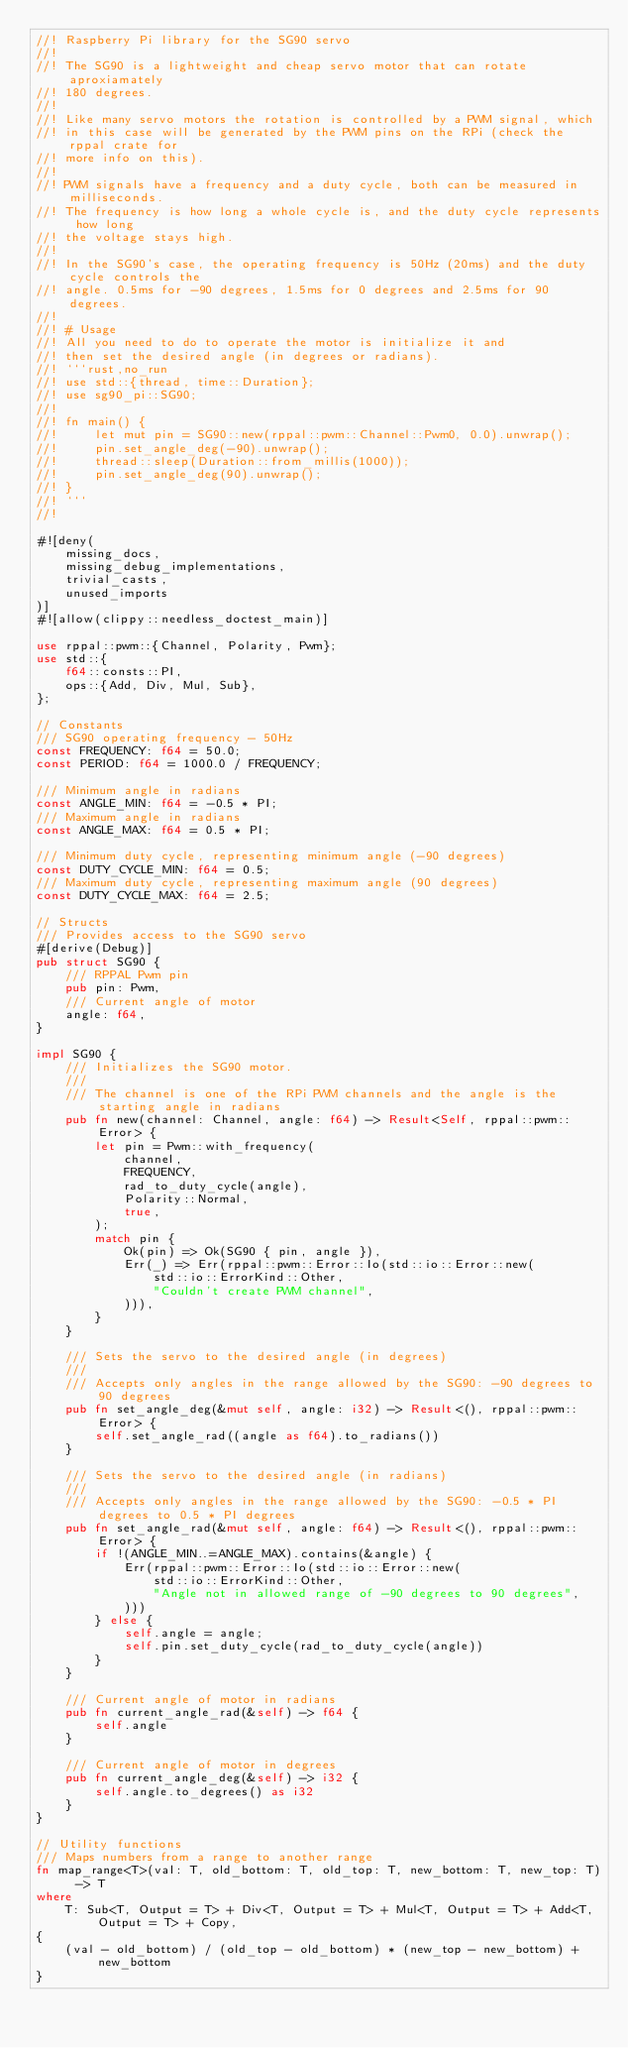<code> <loc_0><loc_0><loc_500><loc_500><_Rust_>//! Raspberry Pi library for the SG90 servo
//!
//! The SG90 is a lightweight and cheap servo motor that can rotate aproxiamately
//! 180 degrees.
//!
//! Like many servo motors the rotation is controlled by a PWM signal, which
//! in this case will be generated by the PWM pins on the RPi (check the rppal crate for
//! more info on this).
//!
//! PWM signals have a frequency and a duty cycle, both can be measured in milliseconds.
//! The frequency is how long a whole cycle is, and the duty cycle represents how long
//! the voltage stays high.
//!
//! In the SG90's case, the operating frequency is 50Hz (20ms) and the duty cycle controls the
//! angle. 0.5ms for -90 degrees, 1.5ms for 0 degrees and 2.5ms for 90 degrees.
//!
//! # Usage
//! All you need to do to operate the motor is initialize it and
//! then set the desired angle (in degrees or radians).
//! ```rust,no_run
//! use std::{thread, time::Duration};
//! use sg90_pi::SG90;
//!
//! fn main() {
//!     let mut pin = SG90::new(rppal::pwm::Channel::Pwm0, 0.0).unwrap();
//!     pin.set_angle_deg(-90).unwrap();
//!     thread::sleep(Duration::from_millis(1000));
//!     pin.set_angle_deg(90).unwrap();
//! }
//! ```
//!

#![deny(
    missing_docs,
    missing_debug_implementations,
    trivial_casts,
    unused_imports
)]
#![allow(clippy::needless_doctest_main)]

use rppal::pwm::{Channel, Polarity, Pwm};
use std::{
    f64::consts::PI,
    ops::{Add, Div, Mul, Sub},
};

// Constants
/// SG90 operating frequency - 50Hz
const FREQUENCY: f64 = 50.0;
const PERIOD: f64 = 1000.0 / FREQUENCY;

/// Minimum angle in radians
const ANGLE_MIN: f64 = -0.5 * PI;
/// Maximum angle in radians
const ANGLE_MAX: f64 = 0.5 * PI;

/// Minimum duty cycle, representing minimum angle (-90 degrees)
const DUTY_CYCLE_MIN: f64 = 0.5;
/// Maximum duty cycle, representing maximum angle (90 degrees)
const DUTY_CYCLE_MAX: f64 = 2.5;

// Structs
/// Provides access to the SG90 servo
#[derive(Debug)]
pub struct SG90 {
    /// RPPAL Pwm pin
    pub pin: Pwm,
    /// Current angle of motor
    angle: f64,
}

impl SG90 {
    /// Initializes the SG90 motor.
    ///
    /// The channel is one of the RPi PWM channels and the angle is the starting angle in radians
    pub fn new(channel: Channel, angle: f64) -> Result<Self, rppal::pwm::Error> {
        let pin = Pwm::with_frequency(
            channel,
            FREQUENCY,
            rad_to_duty_cycle(angle),
            Polarity::Normal,
            true,
        );
        match pin {
            Ok(pin) => Ok(SG90 { pin, angle }),
            Err(_) => Err(rppal::pwm::Error::Io(std::io::Error::new(
                std::io::ErrorKind::Other,
                "Couldn't create PWM channel",
            ))),
        }
    }

    /// Sets the servo to the desired angle (in degrees)
    ///
    /// Accepts only angles in the range allowed by the SG90: -90 degrees to 90 degrees
    pub fn set_angle_deg(&mut self, angle: i32) -> Result<(), rppal::pwm::Error> {
        self.set_angle_rad((angle as f64).to_radians())
    }

    /// Sets the servo to the desired angle (in radians)
    ///
    /// Accepts only angles in the range allowed by the SG90: -0.5 * PI degrees to 0.5 * PI degrees
    pub fn set_angle_rad(&mut self, angle: f64) -> Result<(), rppal::pwm::Error> {
        if !(ANGLE_MIN..=ANGLE_MAX).contains(&angle) {
            Err(rppal::pwm::Error::Io(std::io::Error::new(
                std::io::ErrorKind::Other,
                "Angle not in allowed range of -90 degrees to 90 degrees",
            )))
        } else {
            self.angle = angle;
            self.pin.set_duty_cycle(rad_to_duty_cycle(angle))
        }
    }

    /// Current angle of motor in radians
    pub fn current_angle_rad(&self) -> f64 {
        self.angle
    }

    /// Current angle of motor in degrees
    pub fn current_angle_deg(&self) -> i32 {
        self.angle.to_degrees() as i32
    }
}

// Utility functions
/// Maps numbers from a range to another range
fn map_range<T>(val: T, old_bottom: T, old_top: T, new_bottom: T, new_top: T) -> T
where
    T: Sub<T, Output = T> + Div<T, Output = T> + Mul<T, Output = T> + Add<T, Output = T> + Copy,
{
    (val - old_bottom) / (old_top - old_bottom) * (new_top - new_bottom) + new_bottom
}
</code> 